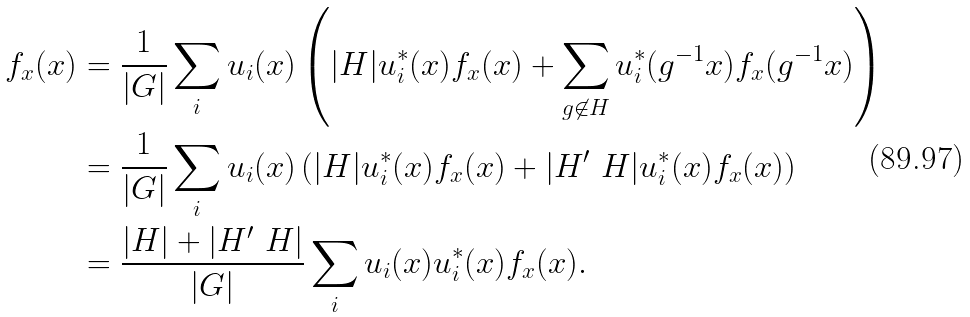Convert formula to latex. <formula><loc_0><loc_0><loc_500><loc_500>f _ { x } ( x ) & = \frac { 1 } { | G | } \sum _ { i } u _ { i } ( x ) \left ( | H | u _ { i } ^ { * } ( x ) f _ { x } ( x ) + \sum _ { g \not \in H } u _ { i } ^ { * } ( g ^ { - 1 } x ) f _ { x } ( g ^ { - 1 } x ) \right ) \\ & = \frac { 1 } { | G | } \sum _ { i } u _ { i } ( x ) \left ( | H | u _ { i } ^ { * } ( x ) f _ { x } ( x ) + | H ^ { \prime } \ H | u _ { i } ^ { * } ( x ) f _ { x } ( x ) \right ) \\ & = \frac { | H | + | H ^ { \prime } \ H | } { | G | } \sum _ { i } u _ { i } ( x ) u _ { i } ^ { * } ( x ) f _ { x } ( x ) .</formula> 